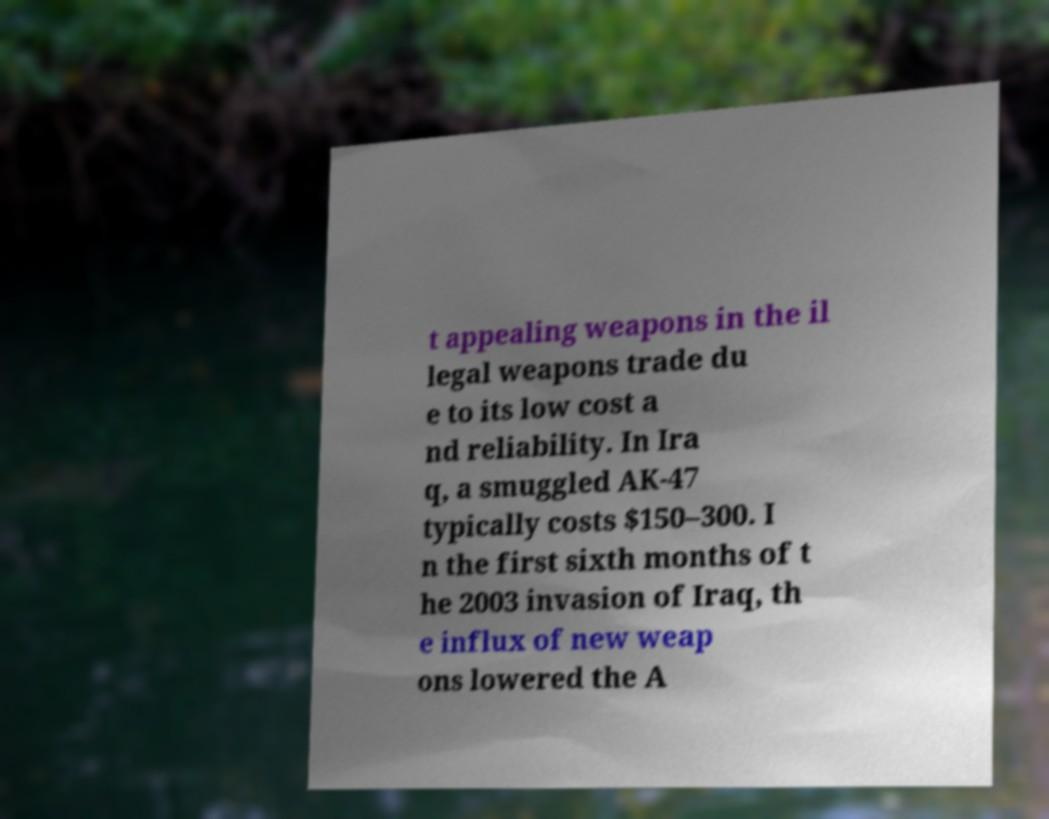Could you extract and type out the text from this image? t appealing weapons in the il legal weapons trade du e to its low cost a nd reliability. In Ira q, a smuggled AK-47 typically costs $150–300. I n the first sixth months of t he 2003 invasion of Iraq, th e influx of new weap ons lowered the A 